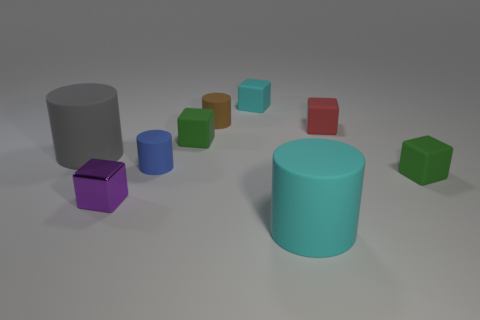Subtract all brown cylinders. How many cylinders are left? 3 Subtract all red cylinders. How many green cubes are left? 2 Subtract 2 cylinders. How many cylinders are left? 2 Subtract all cyan cylinders. How many cylinders are left? 3 Add 1 blue objects. How many objects exist? 10 Subtract all blocks. How many objects are left? 4 Subtract all cyan cubes. Subtract all purple cylinders. How many cubes are left? 4 Subtract all small cyan rubber spheres. Subtract all big cyan matte cylinders. How many objects are left? 8 Add 1 small brown things. How many small brown things are left? 2 Add 1 big gray blocks. How many big gray blocks exist? 1 